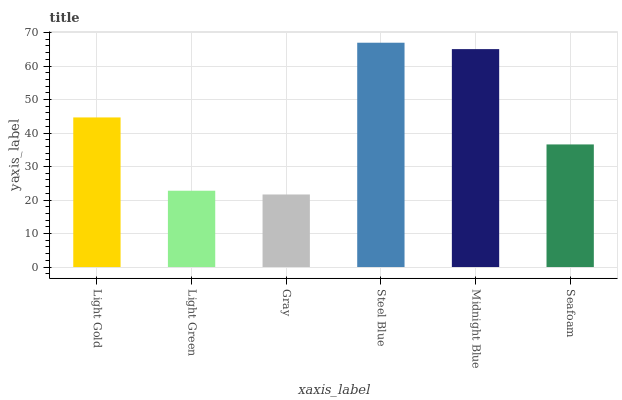Is Light Green the minimum?
Answer yes or no. No. Is Light Green the maximum?
Answer yes or no. No. Is Light Gold greater than Light Green?
Answer yes or no. Yes. Is Light Green less than Light Gold?
Answer yes or no. Yes. Is Light Green greater than Light Gold?
Answer yes or no. No. Is Light Gold less than Light Green?
Answer yes or no. No. Is Light Gold the high median?
Answer yes or no. Yes. Is Seafoam the low median?
Answer yes or no. Yes. Is Light Green the high median?
Answer yes or no. No. Is Gray the low median?
Answer yes or no. No. 